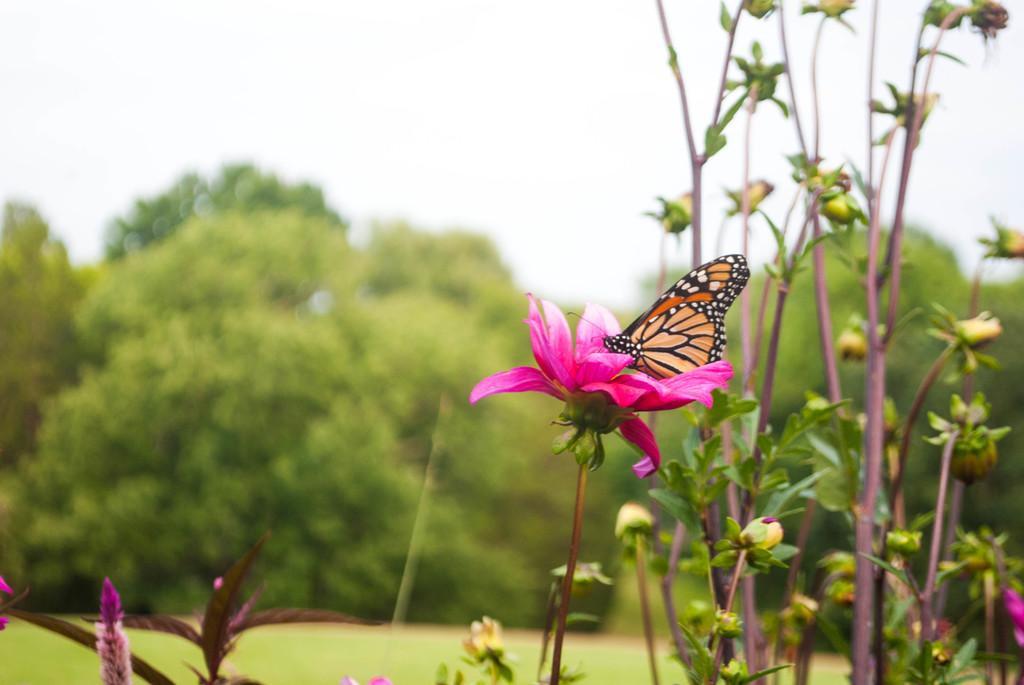In one or two sentences, can you explain what this image depicts? In this image, we can see some plants, there is a butterfly sitting on the pink color flower, there are some green trees, at the top there is a sky. 